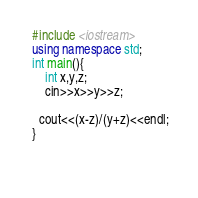<code> <loc_0><loc_0><loc_500><loc_500><_C++_> #include <iostream>
 using namespace std;
 int main(){
     int x,y,z;
     cin>>x>>y>>z;
     
   cout<<(x-z)/(y+z)<<endl;
 }

      </code> 